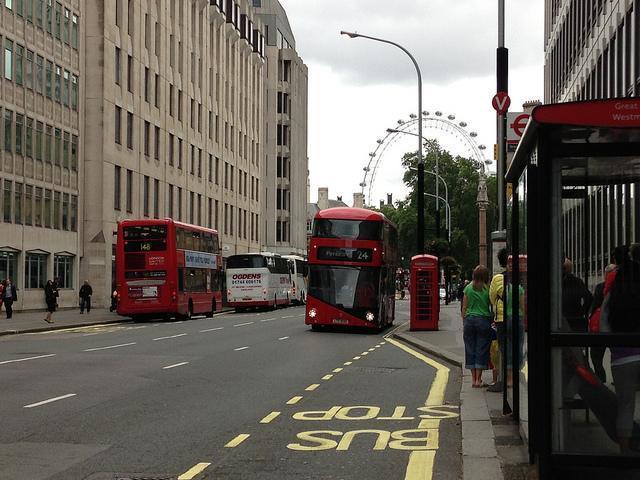How many people are in the photo?
Give a very brief answer. 2. How many buses are there?
Give a very brief answer. 3. 